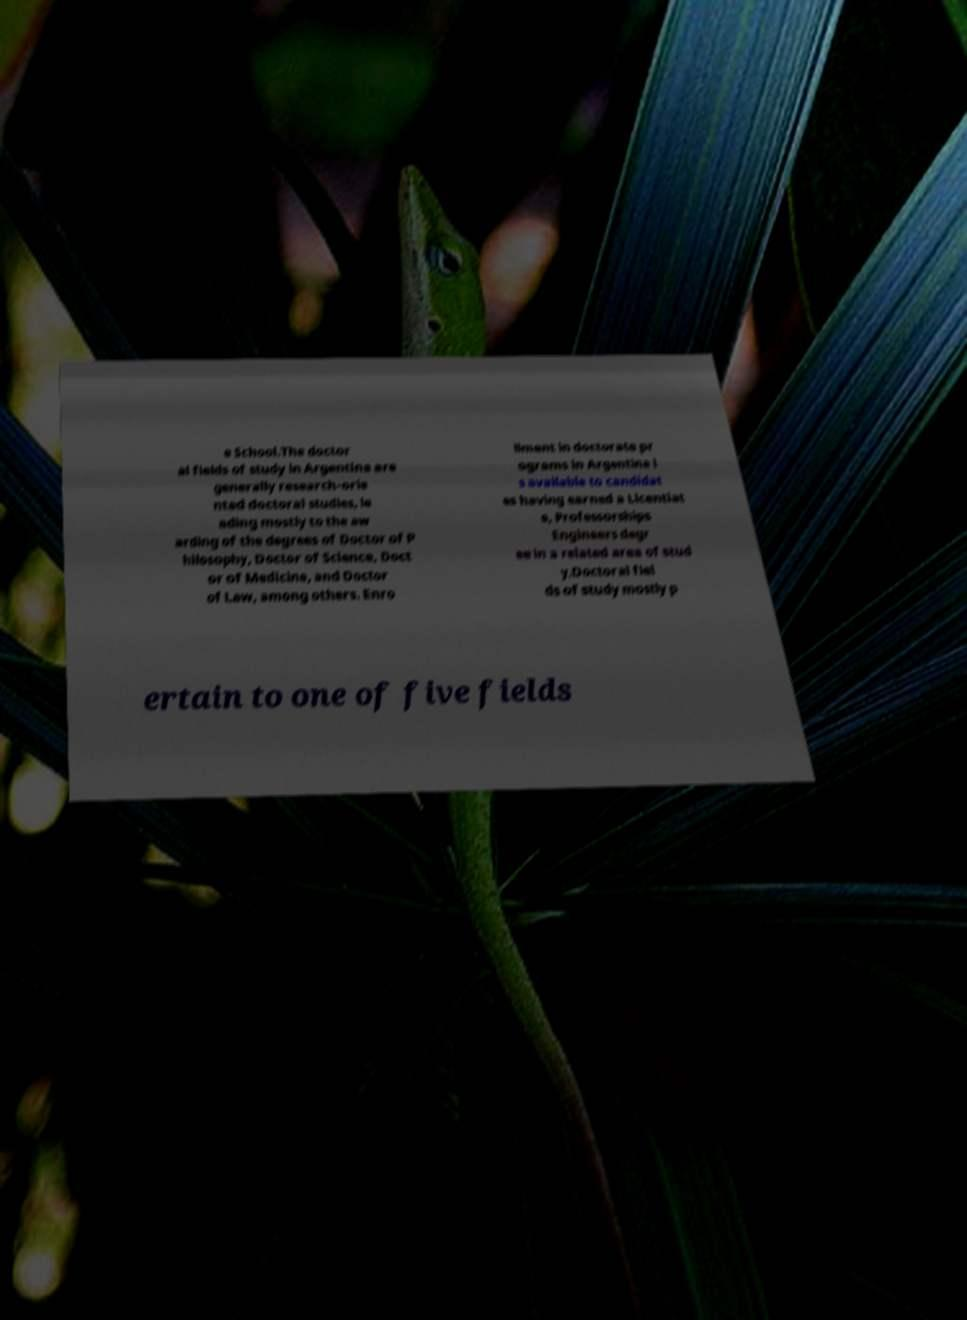Please read and relay the text visible in this image. What does it say? e School.The doctor al fields of study in Argentina are generally research-orie nted doctoral studies, le ading mostly to the aw arding of the degrees of Doctor of P hilosophy, Doctor of Science, Doct or of Medicine, and Doctor of Law, among others. Enro llment in doctorate pr ograms in Argentina i s available to candidat es having earned a Licentiat e, Professorships Engineers degr ee in a related area of stud y.Doctoral fiel ds of study mostly p ertain to one of five fields 